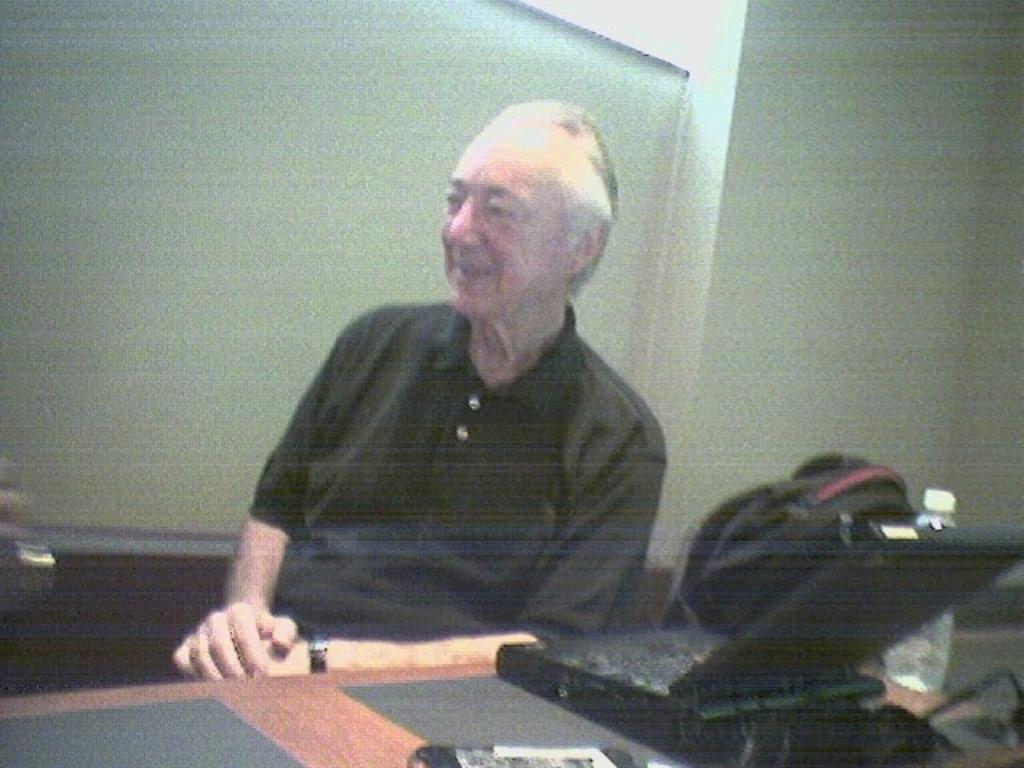What is located at the bottom of the image? There is a table at the bottom of the image. What electronic device is on the table? A laptop is present on the table. What else can be seen on the table? There is a bottle and other unspecified things on the table. Who is behind the table? There is a man behind the table. What is the man holding? The man has a bag. What is visible behind the man? There is a wall behind the man. What type of surprise is the man holding in the image? There is no surprise present in the image; the man is holding a bag. What cable is connected to the laptop in the image? There is no cable connected to the laptop in the image; the provided facts do not mention any cables. 